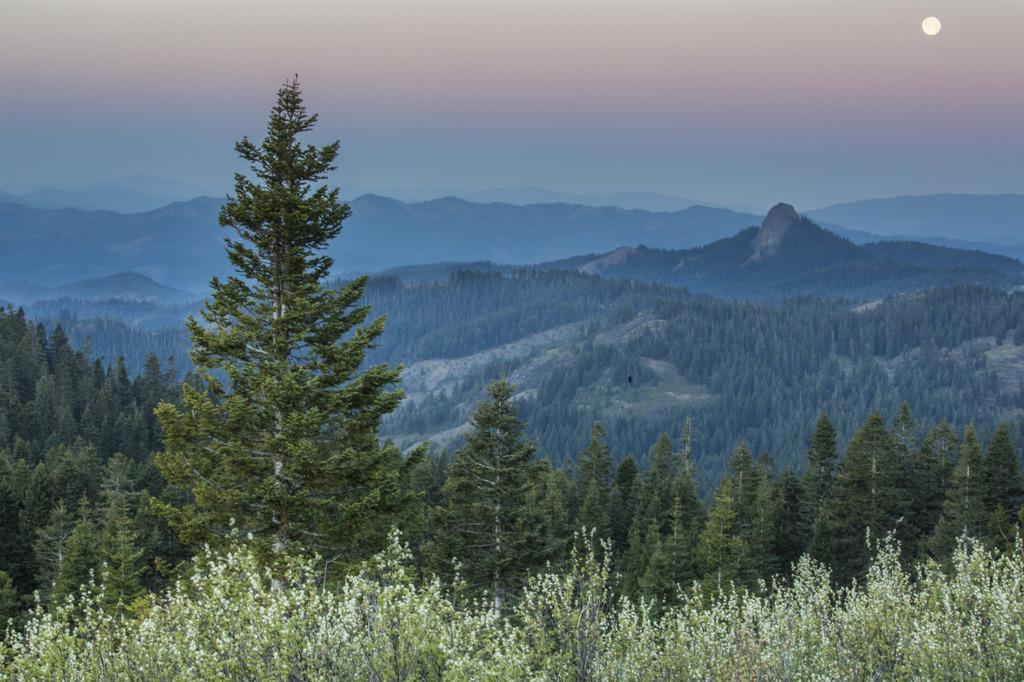Can you describe this image briefly? In this picture we can see trees and in the background we can see mountains, sky. 